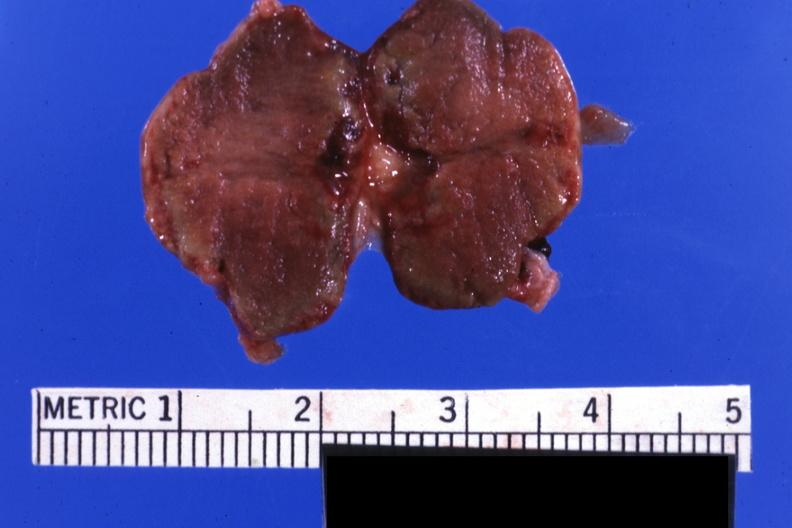does myocardium show fixed tissue but good color gland not recognizable as such?
Answer the question using a single word or phrase. No 